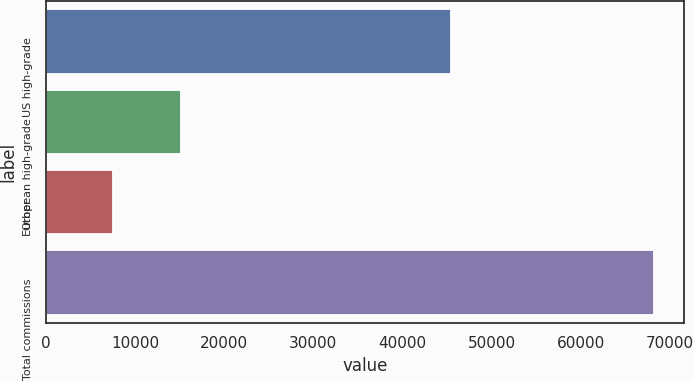Convert chart to OTSL. <chart><loc_0><loc_0><loc_500><loc_500><bar_chart><fcel>US high-grade<fcel>European high-grade<fcel>Other<fcel>Total commissions<nl><fcel>45465<fcel>15142<fcel>7565<fcel>68172<nl></chart> 